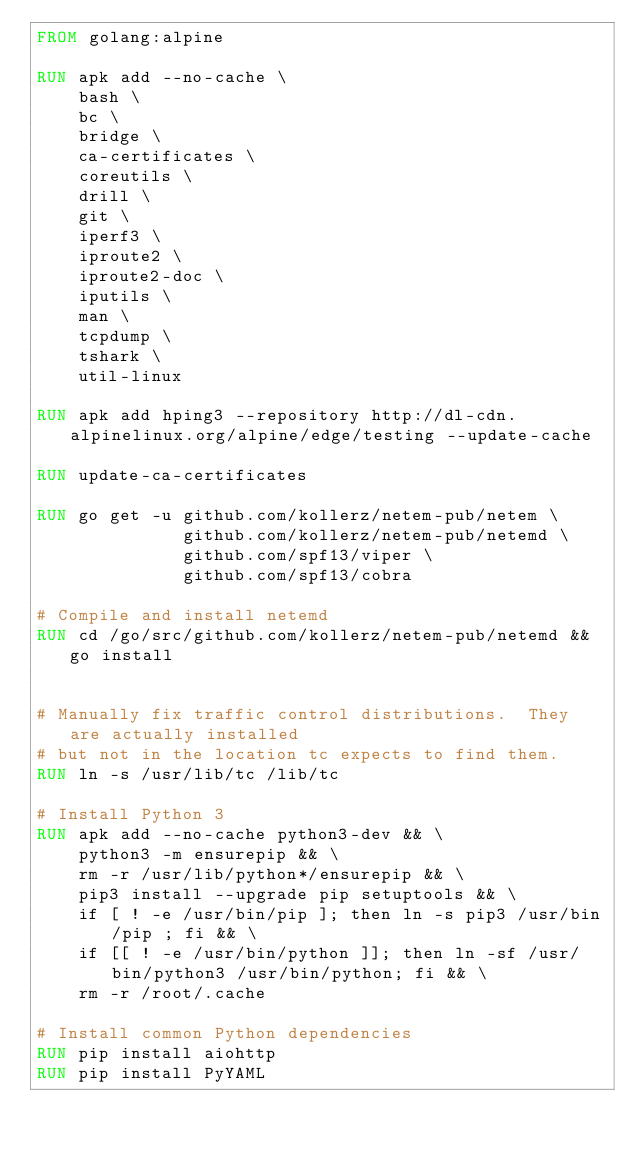Convert code to text. <code><loc_0><loc_0><loc_500><loc_500><_Dockerfile_>FROM golang:alpine

RUN apk add --no-cache \
    bash \
    bc \
    bridge \
    ca-certificates \
    coreutils \
    drill \
    git \
    iperf3 \
    iproute2 \
    iproute2-doc \
    iputils \
    man \
    tcpdump \
    tshark \
    util-linux

RUN apk add hping3 --repository http://dl-cdn.alpinelinux.org/alpine/edge/testing --update-cache

RUN update-ca-certificates

RUN go get -u github.com/kollerz/netem-pub/netem \
              github.com/kollerz/netem-pub/netemd \
              github.com/spf13/viper \
              github.com/spf13/cobra

# Compile and install netemd
RUN cd /go/src/github.com/kollerz/netem-pub/netemd && go install


# Manually fix traffic control distributions.  They are actually installed
# but not in the location tc expects to find them.
RUN ln -s /usr/lib/tc /lib/tc

# Install Python 3
RUN apk add --no-cache python3-dev && \
    python3 -m ensurepip && \
    rm -r /usr/lib/python*/ensurepip && \
    pip3 install --upgrade pip setuptools && \
    if [ ! -e /usr/bin/pip ]; then ln -s pip3 /usr/bin/pip ; fi && \
    if [[ ! -e /usr/bin/python ]]; then ln -sf /usr/bin/python3 /usr/bin/python; fi && \
    rm -r /root/.cache

# Install common Python dependencies
RUN pip install aiohttp
RUN pip install PyYAML
</code> 